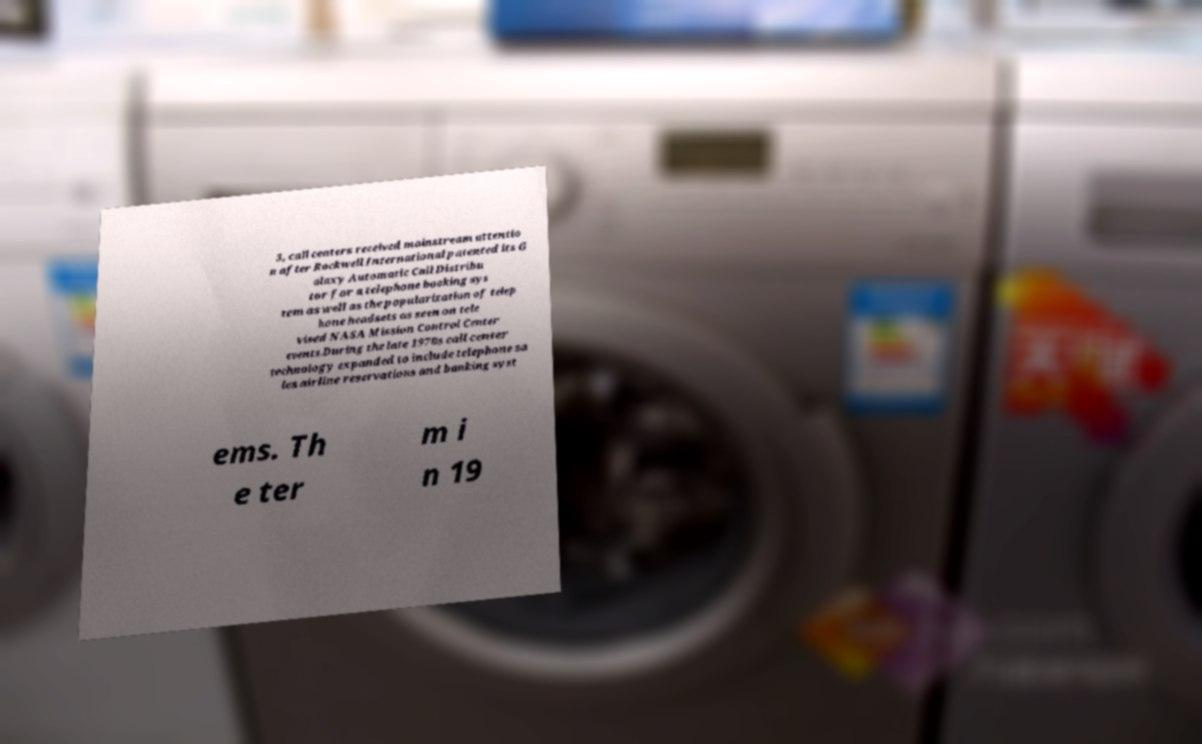Please identify and transcribe the text found in this image. 3, call centers received mainstream attentio n after Rockwell International patented its G alaxy Automatic Call Distribu tor for a telephone booking sys tem as well as the popularization of telep hone headsets as seen on tele vised NASA Mission Control Center events.During the late 1970s call center technology expanded to include telephone sa les airline reservations and banking syst ems. Th e ter m i n 19 